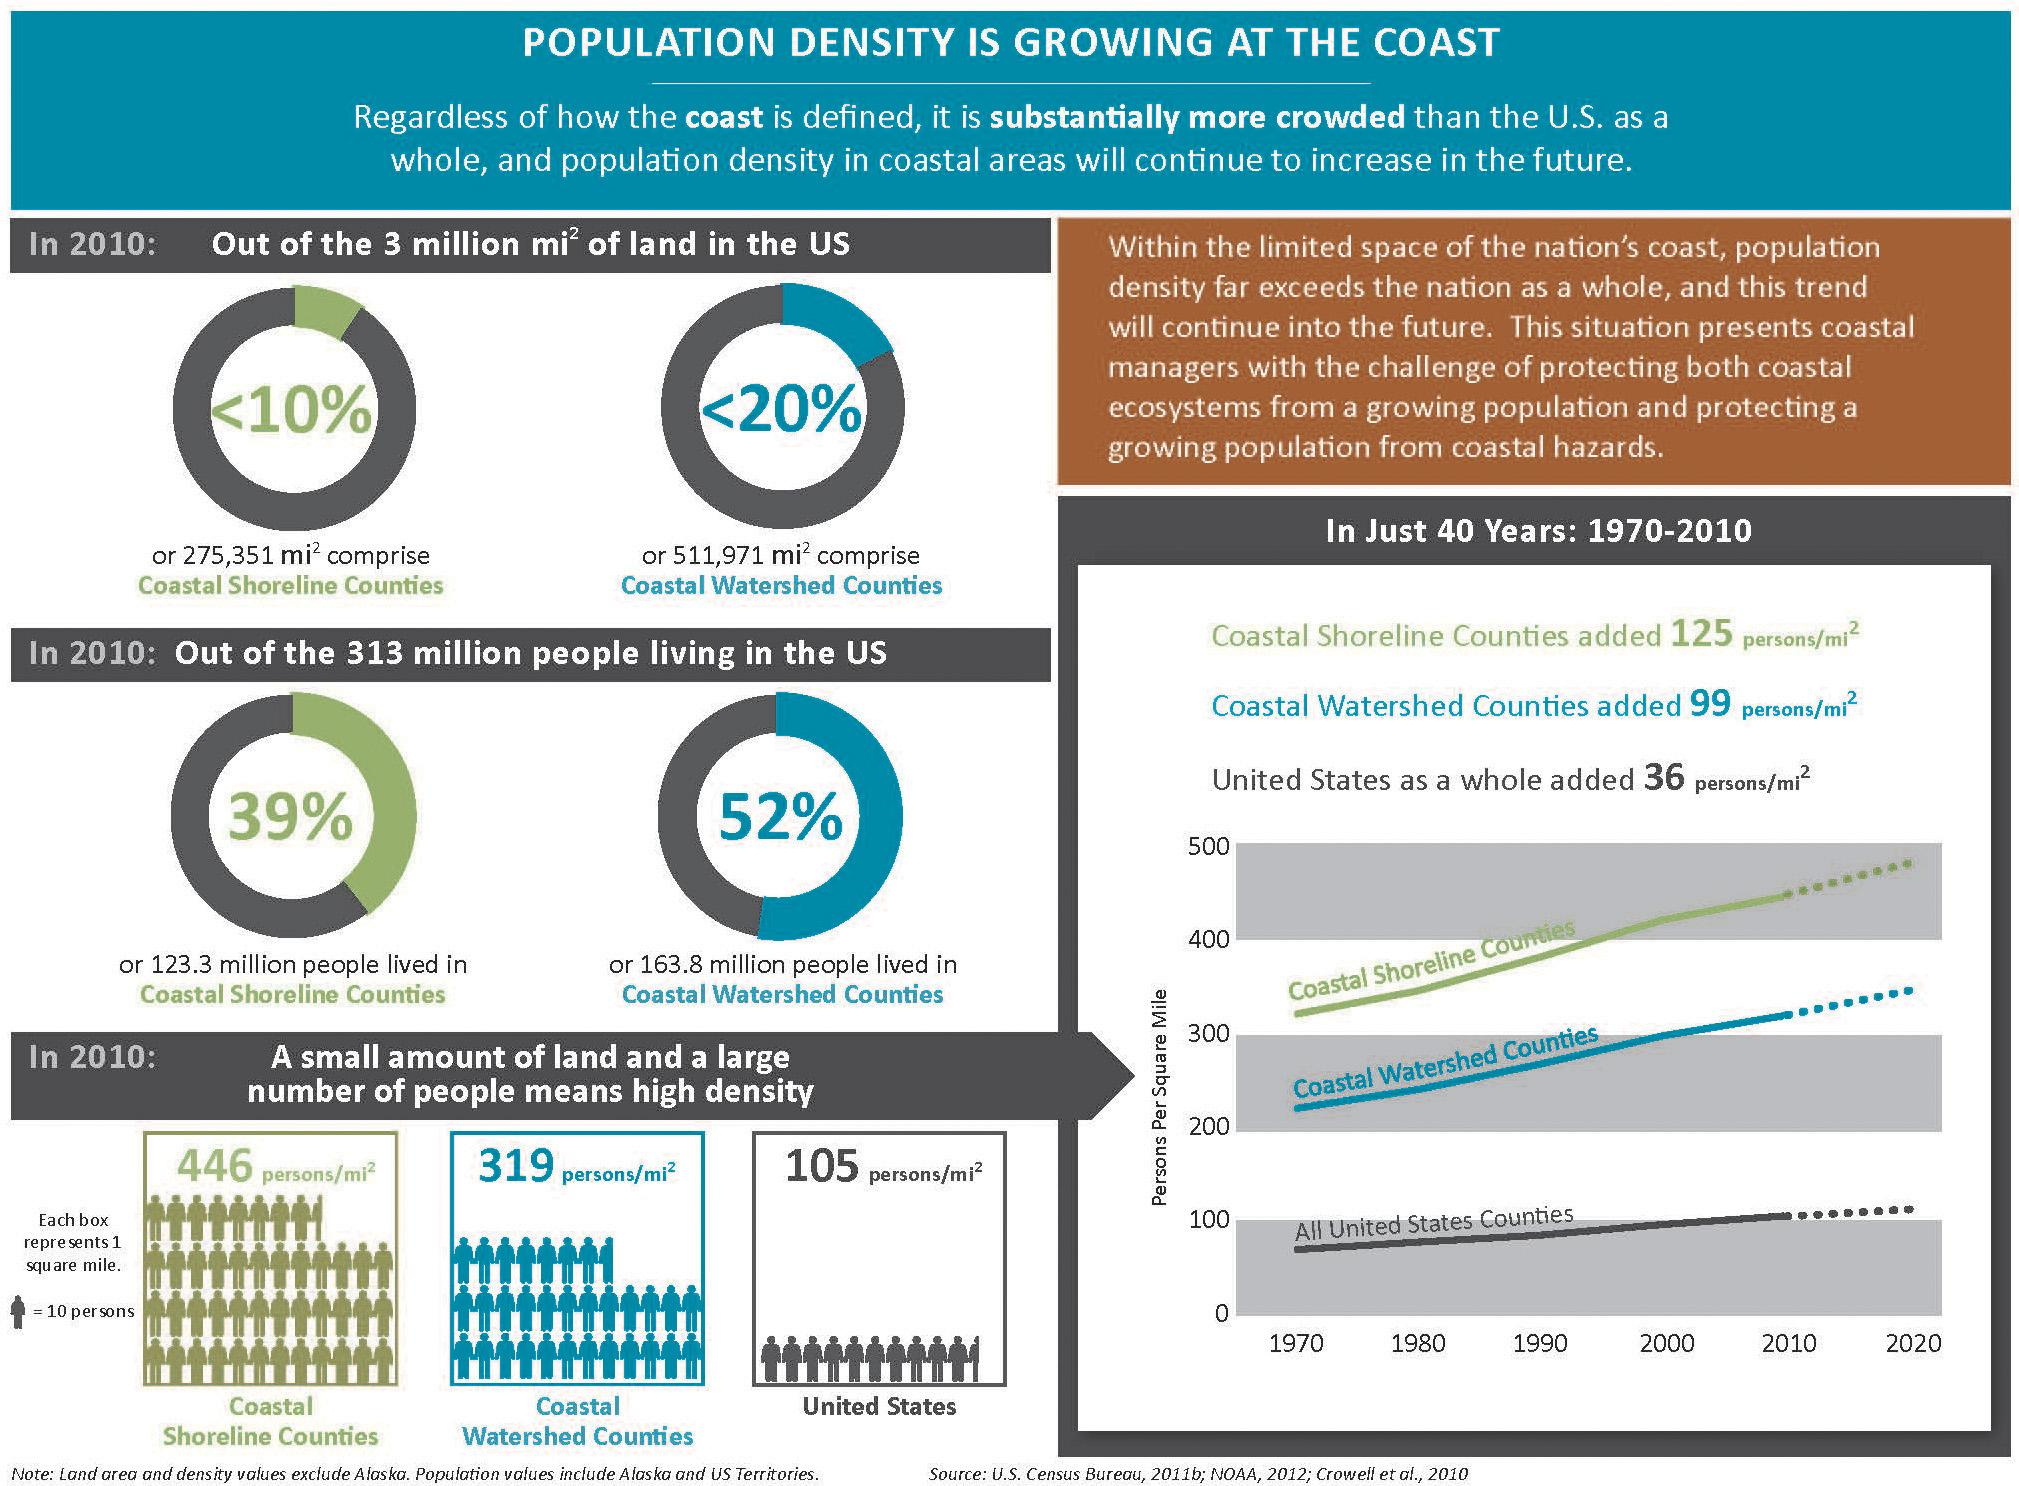Point out several critical features in this image. In the United States, approximately 61% of the population does not reside in coastal shoreline counties. According to data, 48% of people have not lived in Coastal Watershed Counties. 